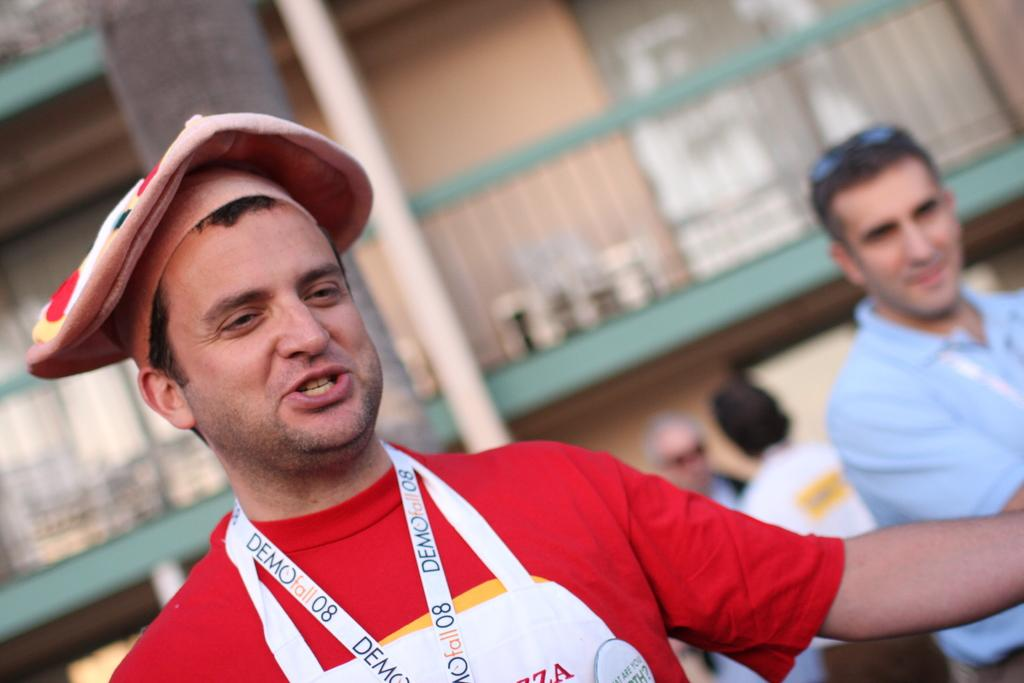Provide a one-sentence caption for the provided image. Man wearing a necklace which says Demofall08 on it. 